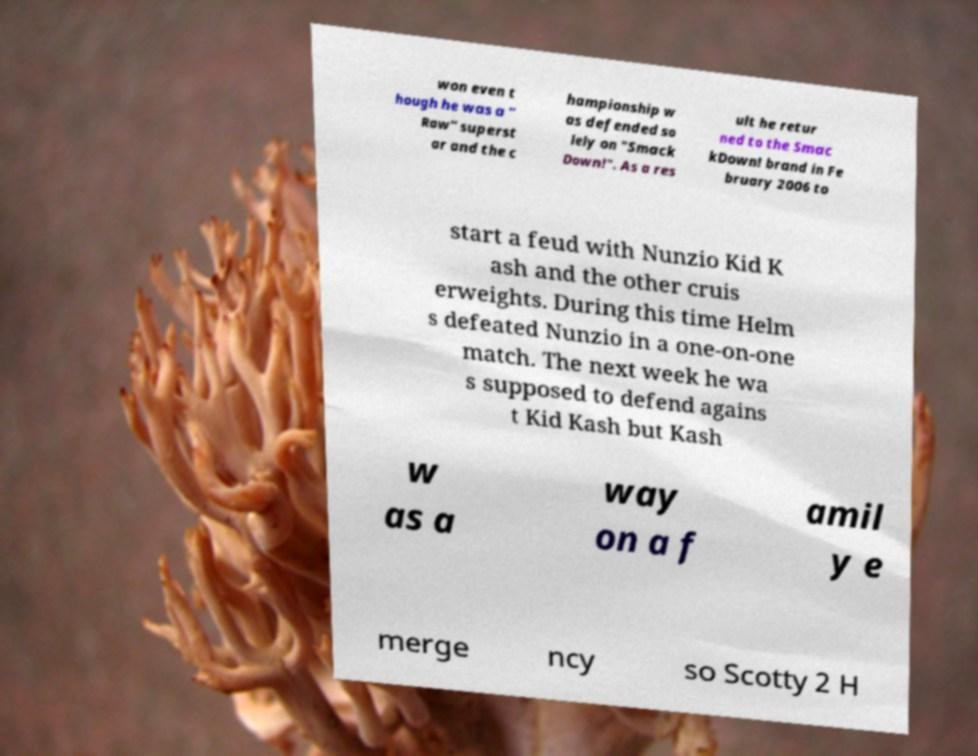Please read and relay the text visible in this image. What does it say? won even t hough he was a " Raw" superst ar and the c hampionship w as defended so lely on "Smack Down!". As a res ult he retur ned to the Smac kDown! brand in Fe bruary 2006 to start a feud with Nunzio Kid K ash and the other cruis erweights. During this time Helm s defeated Nunzio in a one-on-one match. The next week he wa s supposed to defend agains t Kid Kash but Kash w as a way on a f amil y e merge ncy so Scotty 2 H 